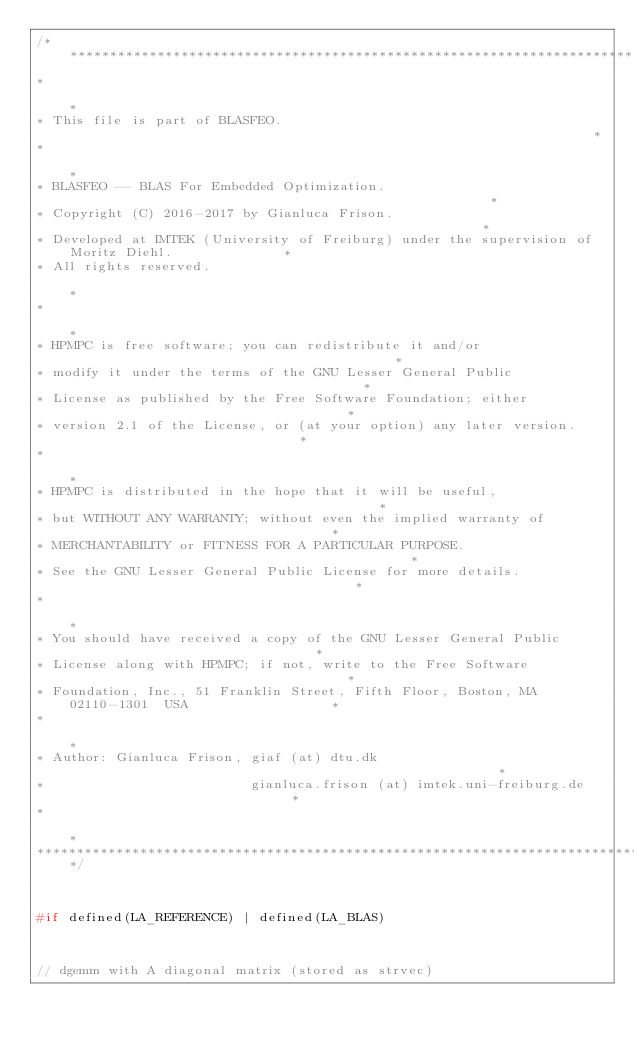Convert code to text. <code><loc_0><loc_0><loc_500><loc_500><_C_>/**************************************************************************************************
*                                                                                                 *
* This file is part of BLASFEO.                                                                   *
*                                                                                                 *
* BLASFEO -- BLAS For Embedded Optimization.                                                      *
* Copyright (C) 2016-2017 by Gianluca Frison.                                                     *
* Developed at IMTEK (University of Freiburg) under the supervision of Moritz Diehl.              *
* All rights reserved.                                                                            *
*                                                                                                 *
* HPMPC is free software; you can redistribute it and/or                                          *
* modify it under the terms of the GNU Lesser General Public                                      *
* License as published by the Free Software Foundation; either                                    *
* version 2.1 of the License, or (at your option) any later version.                              *
*                                                                                                 *
* HPMPC is distributed in the hope that it will be useful,                                        *
* but WITHOUT ANY WARRANTY; without even the implied warranty of                                  *
* MERCHANTABILITY or FITNESS FOR A PARTICULAR PURPOSE.                                            *
* See the GNU Lesser General Public License for more details.                                     *
*                                                                                                 *
* You should have received a copy of the GNU Lesser General Public                                *
* License along with HPMPC; if not, write to the Free Software                                    *
* Foundation, Inc., 51 Franklin Street, Fifth Floor, Boston, MA  02110-1301  USA                  *
*                                                                                                 *
* Author: Gianluca Frison, giaf (at) dtu.dk                                                       *
*                          gianluca.frison (at) imtek.uni-freiburg.de                             *
*                                                                                                 *
**************************************************************************************************/



#if defined(LA_REFERENCE) | defined(LA_BLAS) 



// dgemm with A diagonal matrix (stored as strvec)</code> 